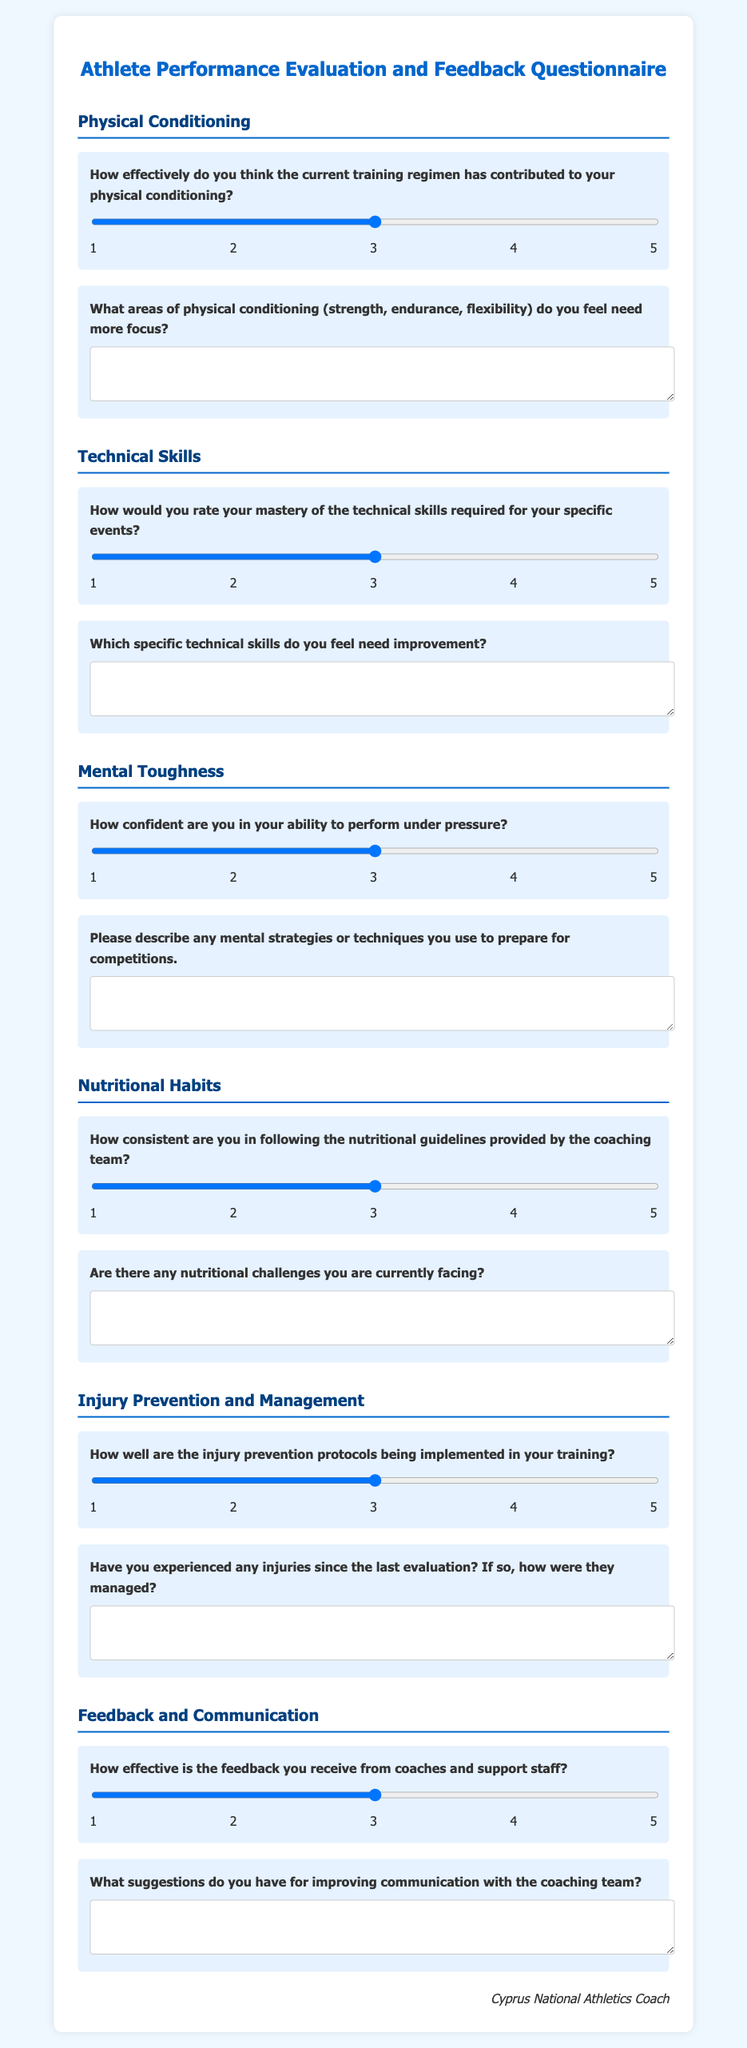What is the title of the document? The title is the main heading of the questionnaire, which provides an overview of its purpose.
Answer: Athlete Performance Evaluation and Feedback Questionnaire How many sections are there in the questionnaire? The document is organized into distinct sections that cover different performance aspects for evaluation.
Answer: 6 What is the scale used for rating physical conditioning effectiveness? The rating scale is specified for evaluating the effectiveness of physical conditioning, indicating the range of possible responses.
Answer: 1 to 5 Which area requires more focus according to the second question in Physical Conditioning? This area is referred to in the question that prompts the athlete to identify specific conditioning aspects needing attention.
Answer: Strength, endurance, flexibility What specific skill is being evaluated in the Technical Skills section? The focus of the inquiry might relate to the athlete's proficiency level with essential skills relevant to their sport.
Answer: Mastery of technical skills What aspect of mental performance is being assessed in the Mental Toughness section? This section addresses the athlete's confidence levels regarding their performance capability under competitive pressures.
Answer: Confidence under pressure What is the purpose of the feedback section in the questionnaire? This section solicits athlete opinions on the effectiveness of coaching communications and invites suggestions for improvements.
Answer: Improve communication How is injury prevention assessed according to the questionnaire? The evaluation of injury protocols is gauged through an effectiveness rating provided by the athlete themselves.
Answer: Injury prevention protocols implementation What type of feedback is requested in the last question of the document? The final inquiry encourages athletes to provide their thoughts on enhancing existing communication practices.
Answer: Suggestions for improving communication 